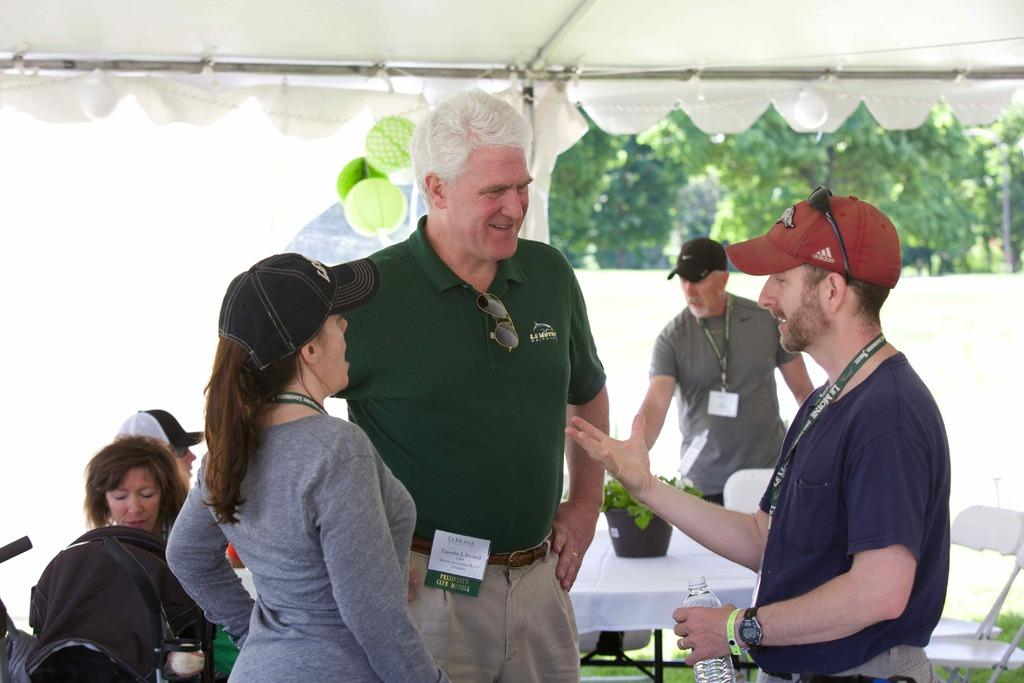What is the main subject of the image? There is a person standing on the ground. What can be seen in the background of the image? There are balloons, a tent, other persons, trees, and a wall in the background. Can you describe the setting of the image? The image appears to be set outdoors, with a person standing on the ground and various objects and people in the background. What type of icicle can be seen hanging from the tent in the image? There is no icicle present in the image, as it is set outdoors and the weather does not appear to be cold enough for icicles to form. 